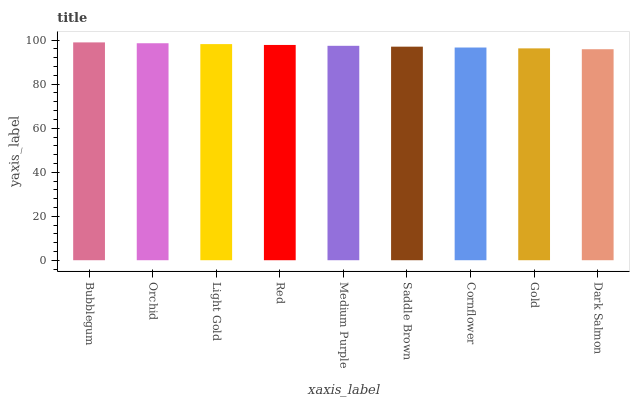Is Dark Salmon the minimum?
Answer yes or no. Yes. Is Bubblegum the maximum?
Answer yes or no. Yes. Is Orchid the minimum?
Answer yes or no. No. Is Orchid the maximum?
Answer yes or no. No. Is Bubblegum greater than Orchid?
Answer yes or no. Yes. Is Orchid less than Bubblegum?
Answer yes or no. Yes. Is Orchid greater than Bubblegum?
Answer yes or no. No. Is Bubblegum less than Orchid?
Answer yes or no. No. Is Medium Purple the high median?
Answer yes or no. Yes. Is Medium Purple the low median?
Answer yes or no. Yes. Is Bubblegum the high median?
Answer yes or no. No. Is Red the low median?
Answer yes or no. No. 